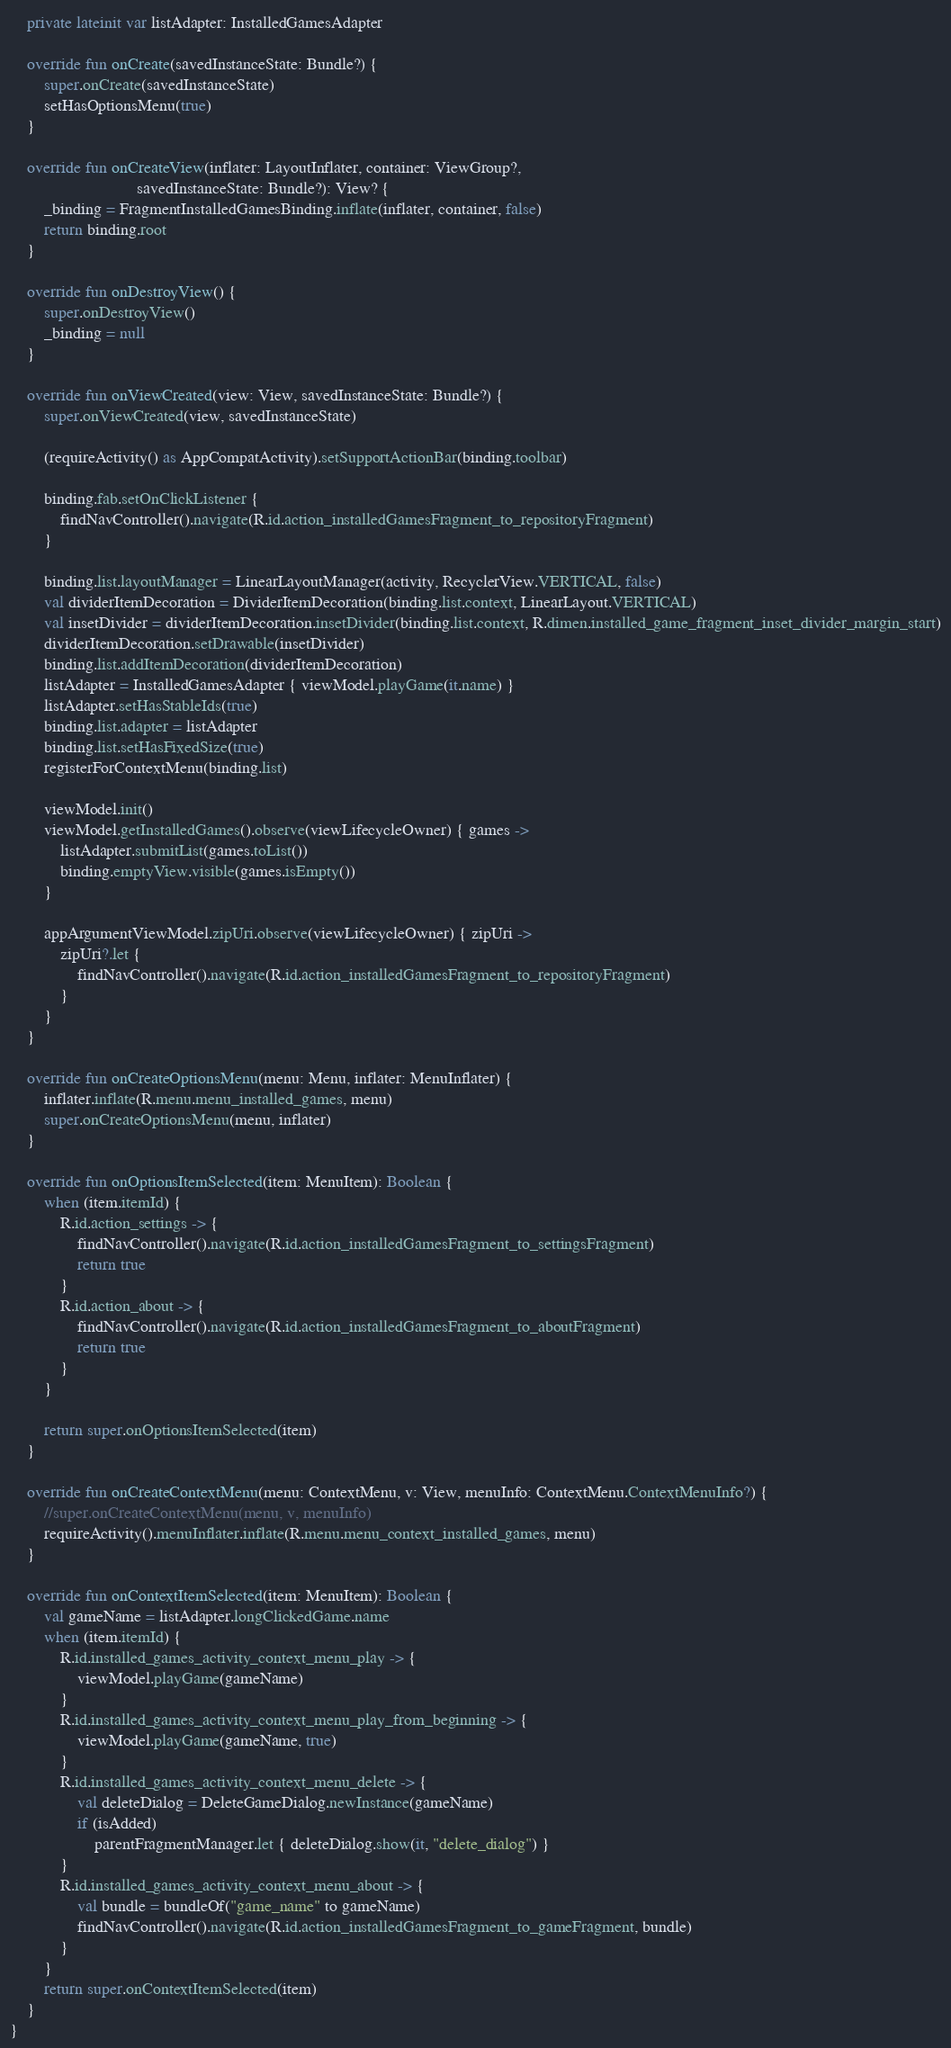Convert code to text. <code><loc_0><loc_0><loc_500><loc_500><_Kotlin_>    private lateinit var listAdapter: InstalledGamesAdapter

    override fun onCreate(savedInstanceState: Bundle?) {
        super.onCreate(savedInstanceState)
        setHasOptionsMenu(true)
    }

    override fun onCreateView(inflater: LayoutInflater, container: ViewGroup?,
                              savedInstanceState: Bundle?): View? {
        _binding = FragmentInstalledGamesBinding.inflate(inflater, container, false)
        return binding.root
    }

    override fun onDestroyView() {
        super.onDestroyView()
        _binding = null
    }

    override fun onViewCreated(view: View, savedInstanceState: Bundle?) {
        super.onViewCreated(view, savedInstanceState)

        (requireActivity() as AppCompatActivity).setSupportActionBar(binding.toolbar)

        binding.fab.setOnClickListener {
            findNavController().navigate(R.id.action_installedGamesFragment_to_repositoryFragment)
        }

        binding.list.layoutManager = LinearLayoutManager(activity, RecyclerView.VERTICAL, false)
        val dividerItemDecoration = DividerItemDecoration(binding.list.context, LinearLayout.VERTICAL)
        val insetDivider = dividerItemDecoration.insetDivider(binding.list.context, R.dimen.installed_game_fragment_inset_divider_margin_start)
        dividerItemDecoration.setDrawable(insetDivider)
        binding.list.addItemDecoration(dividerItemDecoration)
        listAdapter = InstalledGamesAdapter { viewModel.playGame(it.name) }
        listAdapter.setHasStableIds(true)
        binding.list.adapter = listAdapter
        binding.list.setHasFixedSize(true)
        registerForContextMenu(binding.list)

        viewModel.init()
        viewModel.getInstalledGames().observe(viewLifecycleOwner) { games ->
            listAdapter.submitList(games.toList())
            binding.emptyView.visible(games.isEmpty())
        }

        appArgumentViewModel.zipUri.observe(viewLifecycleOwner) { zipUri ->
            zipUri?.let {
                findNavController().navigate(R.id.action_installedGamesFragment_to_repositoryFragment)
            }
        }
    }

    override fun onCreateOptionsMenu(menu: Menu, inflater: MenuInflater) {
        inflater.inflate(R.menu.menu_installed_games, menu)
        super.onCreateOptionsMenu(menu, inflater)
    }

    override fun onOptionsItemSelected(item: MenuItem): Boolean {
        when (item.itemId) {
            R.id.action_settings -> {
                findNavController().navigate(R.id.action_installedGamesFragment_to_settingsFragment)
                return true
            }
            R.id.action_about -> {
                findNavController().navigate(R.id.action_installedGamesFragment_to_aboutFragment)
                return true
            }
        }

        return super.onOptionsItemSelected(item)
    }

    override fun onCreateContextMenu(menu: ContextMenu, v: View, menuInfo: ContextMenu.ContextMenuInfo?) {
        //super.onCreateContextMenu(menu, v, menuInfo)
        requireActivity().menuInflater.inflate(R.menu.menu_context_installed_games, menu)
    }

    override fun onContextItemSelected(item: MenuItem): Boolean {
        val gameName = listAdapter.longClickedGame.name
        when (item.itemId) {
            R.id.installed_games_activity_context_menu_play -> {
                viewModel.playGame(gameName)
            }
            R.id.installed_games_activity_context_menu_play_from_beginning -> {
                viewModel.playGame(gameName, true)
            }
            R.id.installed_games_activity_context_menu_delete -> {
                val deleteDialog = DeleteGameDialog.newInstance(gameName)
                if (isAdded)
                    parentFragmentManager.let { deleteDialog.show(it, "delete_dialog") }
            }
            R.id.installed_games_activity_context_menu_about -> {
                val bundle = bundleOf("game_name" to gameName)
                findNavController().navigate(R.id.action_installedGamesFragment_to_gameFragment, bundle)
            }
        }
        return super.onContextItemSelected(item)
    }
}</code> 